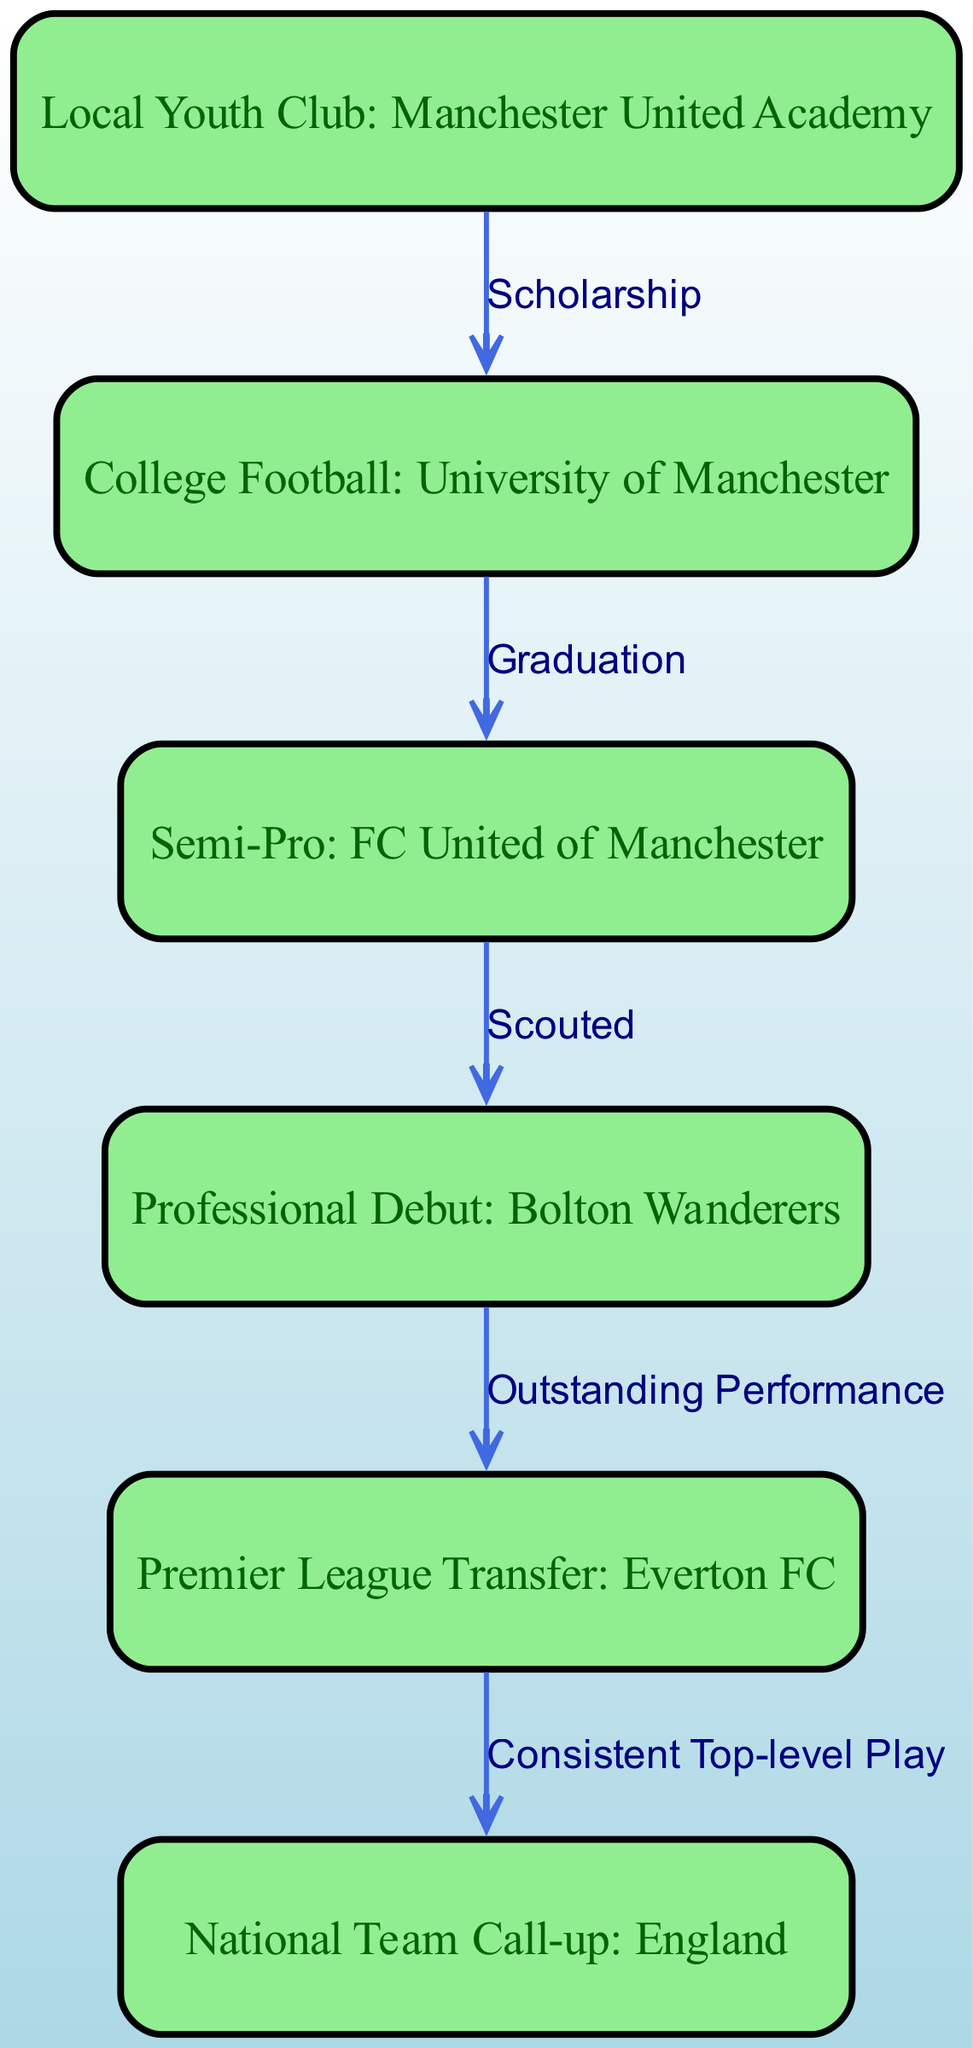What is the first node in Jonathon Coddington's career progression? The first node in the diagram represents Jonathon Coddington's initial step in his career, starting from a local youth club, specifically the Manchester United Academy.
Answer: Local Youth Club: Manchester United Academy How many total nodes are present in the diagram? By counting the nodes listed in the diagram, we find there are six unique stages in Jonathon Coddington's career progression represented by nodes.
Answer: 6 What is the last node in the flow chart? The last node reflects the peak of Jonathon Coddington's career journey, which indicates his national team call-up to represent England.
Answer: National Team Call-up: England Which node follows the "Semi-Pro: FC United of Manchester"? Following the semi-professional stage, as illustrated in the diagram, is the node representing his professional debut with Bolton Wanderers, indicating a progression to the next level in his career.
Answer: Professional Debut: Bolton Wanderers What type of transition happens between "Professional Debut: Bolton Wanderers" and "Premier League Transfer: Everton FC"? The edge between these two nodes is labeled "Outstanding Performance," which signifies that an exceptional performance in his debut led to his transfer to a Premier League team.
Answer: Outstanding Performance How many edges are there in the diagram? By reviewing the connections indicated between nodes, we see there are five edges representing the transitions in Jonathon Coddington's career path.
Answer: 5 What was the primary reason leading to Jonathon's the national team call-up? The transition to the national team call-up is based on his consistent top-level play, as indicated in the flow chart. This connection shows that sustained high performance was crucial for this achievement.
Answer: Consistent Top-level Play Which college did Jonathon attend to play football? The diagram specifies that he played college football at the University of Manchester, indicating where his collegiate career occurred.
Answer: College Football: University of Manchester What achievement is indicated by the transition from the "Premier League Transfer: Everton FC" to "National Team Call-up: England"? The transition here is marked by "Consistent Top-level Play," suggesting that his continuous high-level performance was a significant factor leading to his call-up to the national team.
Answer: Consistent Top-level Play 